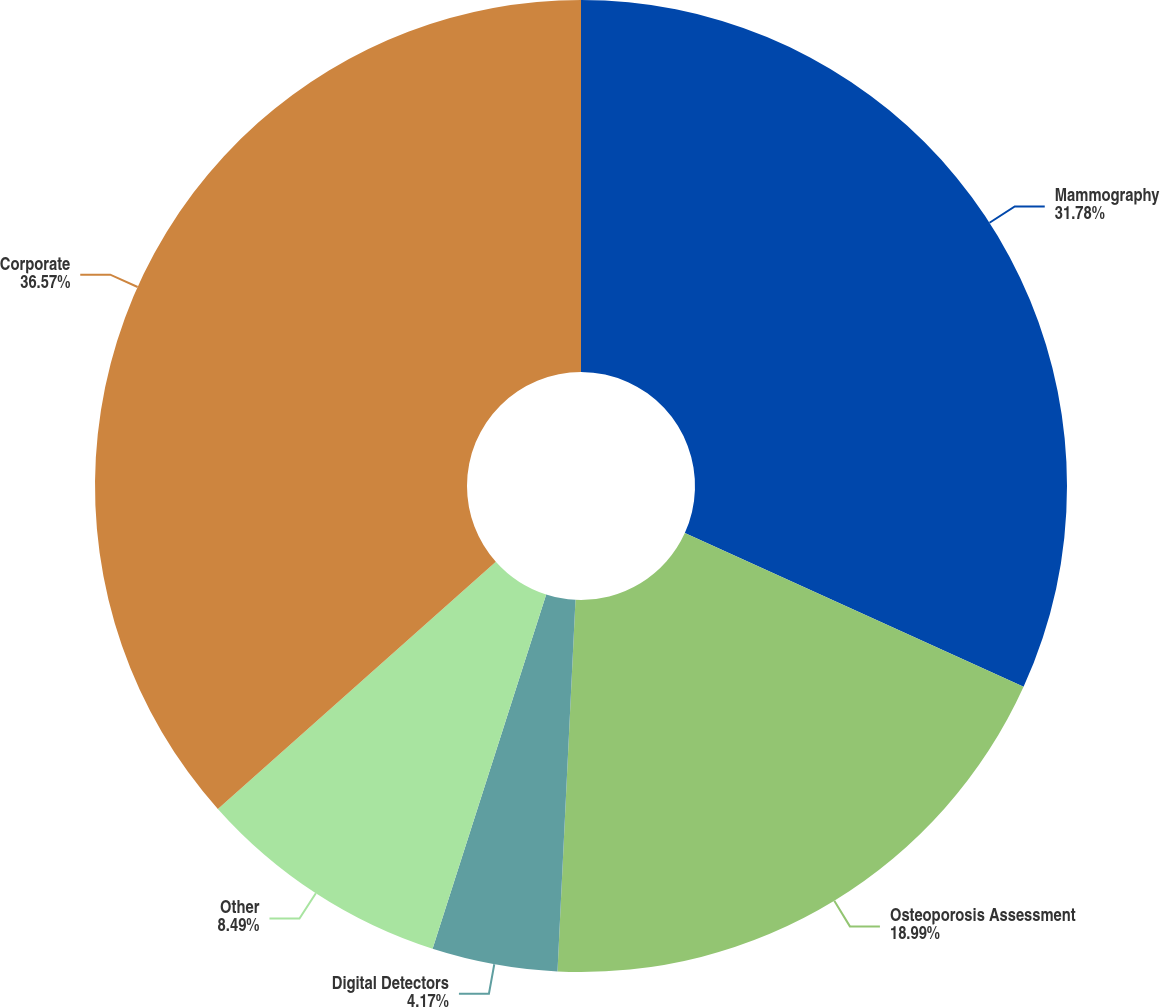Convert chart to OTSL. <chart><loc_0><loc_0><loc_500><loc_500><pie_chart><fcel>Mammography<fcel>Osteoporosis Assessment<fcel>Digital Detectors<fcel>Other<fcel>Corporate<nl><fcel>31.78%<fcel>18.99%<fcel>4.17%<fcel>8.49%<fcel>36.57%<nl></chart> 